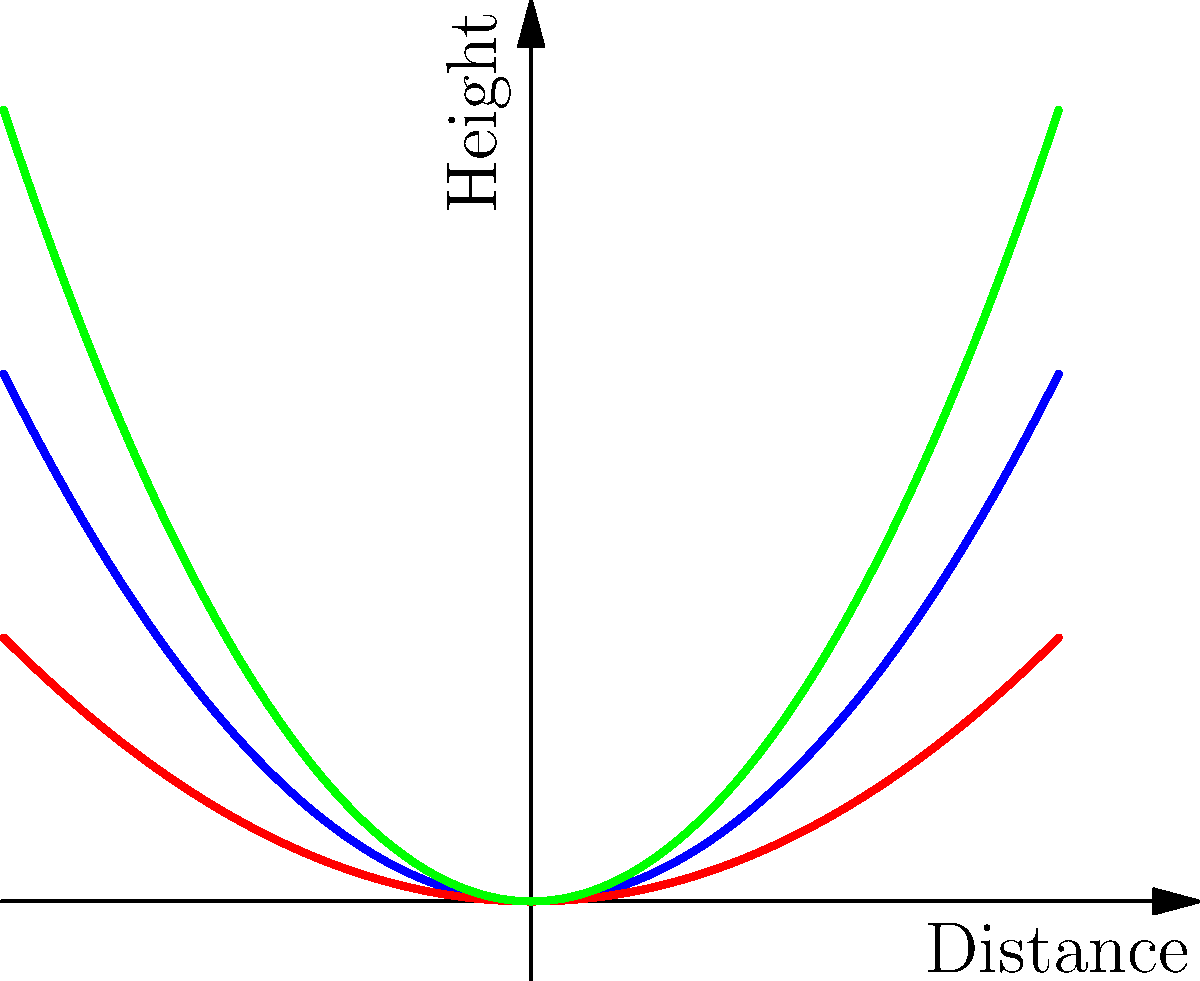Based on the graph showing ball trajectories with different spin rates, which spin rate would likely result in the highest arc for a basketball shot? To determine which spin rate would result in the highest arc for a basketball shot, we need to analyze the curves presented in the graph:

1. The graph shows three curves representing different spin rates: low (red), medium (blue), and high (green).

2. In basketball, a higher arc generally corresponds to a steeper curve that reaches a greater maximum height.

3. Examining the curves:
   - The red curve (low spin) has the shallowest arc.
   - The blue curve (medium spin) has a moderate arc.
   - The green curve (high spin) has the steepest arc and reaches the highest point.

4. The steeper the curve, the more backspin is applied to the ball, which creates more lift and results in a higher arc.

5. In basketball shooting, a higher arc (within reason) is generally desirable as it:
   - Increases the effective size of the hoop (from the ball's perspective)
   - Provides a softer landing on the rim, increasing the chances of a favorable bounce

6. Therefore, based on the graph, the high spin rate (represented by the green curve) would likely result in the highest arc for a basketball shot.
Answer: High spin rate 